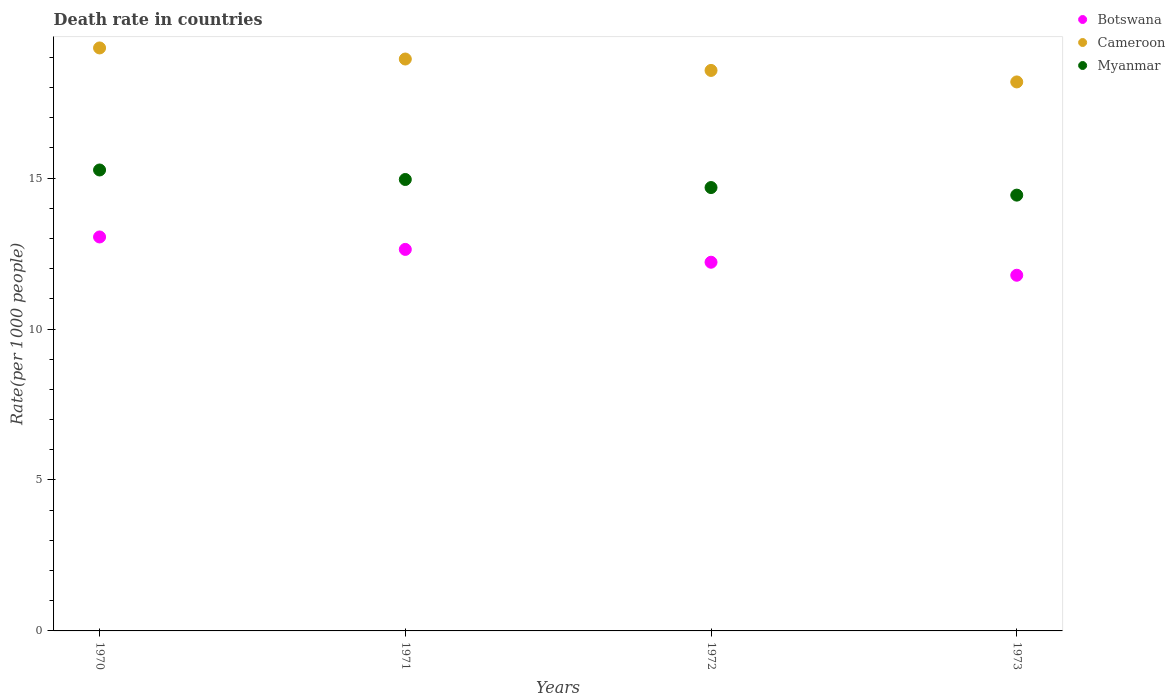Is the number of dotlines equal to the number of legend labels?
Offer a terse response. Yes. What is the death rate in Cameroon in 1972?
Ensure brevity in your answer.  18.57. Across all years, what is the maximum death rate in Botswana?
Your answer should be very brief. 13.05. Across all years, what is the minimum death rate in Botswana?
Offer a terse response. 11.78. What is the total death rate in Cameroon in the graph?
Your answer should be compact. 75.01. What is the difference between the death rate in Myanmar in 1972 and that in 1973?
Make the answer very short. 0.25. What is the difference between the death rate in Myanmar in 1971 and the death rate in Cameroon in 1970?
Your response must be concise. -4.36. What is the average death rate in Cameroon per year?
Your response must be concise. 18.75. In the year 1970, what is the difference between the death rate in Cameroon and death rate in Botswana?
Provide a short and direct response. 6.26. What is the ratio of the death rate in Botswana in 1970 to that in 1973?
Your answer should be very brief. 1.11. Is the death rate in Myanmar in 1970 less than that in 1973?
Give a very brief answer. No. Is the difference between the death rate in Cameroon in 1972 and 1973 greater than the difference between the death rate in Botswana in 1972 and 1973?
Offer a very short reply. No. What is the difference between the highest and the second highest death rate in Cameroon?
Your answer should be very brief. 0.37. What is the difference between the highest and the lowest death rate in Myanmar?
Make the answer very short. 0.83. In how many years, is the death rate in Botswana greater than the average death rate in Botswana taken over all years?
Make the answer very short. 2. Is the sum of the death rate in Myanmar in 1970 and 1972 greater than the maximum death rate in Botswana across all years?
Your response must be concise. Yes. Does the death rate in Cameroon monotonically increase over the years?
Offer a very short reply. No. Is the death rate in Cameroon strictly greater than the death rate in Myanmar over the years?
Your answer should be compact. Yes. How many years are there in the graph?
Give a very brief answer. 4. Are the values on the major ticks of Y-axis written in scientific E-notation?
Your answer should be very brief. No. Does the graph contain any zero values?
Offer a very short reply. No. Where does the legend appear in the graph?
Provide a short and direct response. Top right. How many legend labels are there?
Provide a succinct answer. 3. What is the title of the graph?
Your response must be concise. Death rate in countries. Does "Benin" appear as one of the legend labels in the graph?
Offer a very short reply. No. What is the label or title of the Y-axis?
Keep it short and to the point. Rate(per 1000 people). What is the Rate(per 1000 people) of Botswana in 1970?
Provide a succinct answer. 13.05. What is the Rate(per 1000 people) of Cameroon in 1970?
Give a very brief answer. 19.31. What is the Rate(per 1000 people) of Myanmar in 1970?
Offer a terse response. 15.27. What is the Rate(per 1000 people) of Botswana in 1971?
Your answer should be compact. 12.64. What is the Rate(per 1000 people) in Cameroon in 1971?
Provide a succinct answer. 18.95. What is the Rate(per 1000 people) of Myanmar in 1971?
Offer a very short reply. 14.96. What is the Rate(per 1000 people) in Botswana in 1972?
Your answer should be very brief. 12.21. What is the Rate(per 1000 people) of Cameroon in 1972?
Keep it short and to the point. 18.57. What is the Rate(per 1000 people) of Myanmar in 1972?
Ensure brevity in your answer.  14.69. What is the Rate(per 1000 people) in Botswana in 1973?
Give a very brief answer. 11.78. What is the Rate(per 1000 people) of Cameroon in 1973?
Ensure brevity in your answer.  18.19. What is the Rate(per 1000 people) in Myanmar in 1973?
Your answer should be compact. 14.44. Across all years, what is the maximum Rate(per 1000 people) of Botswana?
Keep it short and to the point. 13.05. Across all years, what is the maximum Rate(per 1000 people) of Cameroon?
Provide a short and direct response. 19.31. Across all years, what is the maximum Rate(per 1000 people) in Myanmar?
Provide a short and direct response. 15.27. Across all years, what is the minimum Rate(per 1000 people) in Botswana?
Your response must be concise. 11.78. Across all years, what is the minimum Rate(per 1000 people) of Cameroon?
Your answer should be very brief. 18.19. Across all years, what is the minimum Rate(per 1000 people) of Myanmar?
Your response must be concise. 14.44. What is the total Rate(per 1000 people) of Botswana in the graph?
Your response must be concise. 49.69. What is the total Rate(per 1000 people) in Cameroon in the graph?
Give a very brief answer. 75.01. What is the total Rate(per 1000 people) of Myanmar in the graph?
Provide a succinct answer. 59.35. What is the difference between the Rate(per 1000 people) in Botswana in 1970 and that in 1971?
Keep it short and to the point. 0.41. What is the difference between the Rate(per 1000 people) of Cameroon in 1970 and that in 1971?
Give a very brief answer. 0.37. What is the difference between the Rate(per 1000 people) of Myanmar in 1970 and that in 1971?
Make the answer very short. 0.32. What is the difference between the Rate(per 1000 people) of Botswana in 1970 and that in 1972?
Offer a terse response. 0.84. What is the difference between the Rate(per 1000 people) in Cameroon in 1970 and that in 1972?
Your response must be concise. 0.74. What is the difference between the Rate(per 1000 people) of Myanmar in 1970 and that in 1972?
Provide a succinct answer. 0.58. What is the difference between the Rate(per 1000 people) in Botswana in 1970 and that in 1973?
Offer a very short reply. 1.27. What is the difference between the Rate(per 1000 people) in Cameroon in 1970 and that in 1973?
Provide a succinct answer. 1.13. What is the difference between the Rate(per 1000 people) of Myanmar in 1970 and that in 1973?
Keep it short and to the point. 0.83. What is the difference between the Rate(per 1000 people) in Botswana in 1971 and that in 1972?
Offer a terse response. 0.42. What is the difference between the Rate(per 1000 people) in Cameroon in 1971 and that in 1972?
Provide a short and direct response. 0.38. What is the difference between the Rate(per 1000 people) of Myanmar in 1971 and that in 1972?
Make the answer very short. 0.27. What is the difference between the Rate(per 1000 people) in Botswana in 1971 and that in 1973?
Make the answer very short. 0.86. What is the difference between the Rate(per 1000 people) in Cameroon in 1971 and that in 1973?
Keep it short and to the point. 0.76. What is the difference between the Rate(per 1000 people) of Myanmar in 1971 and that in 1973?
Offer a very short reply. 0.52. What is the difference between the Rate(per 1000 people) in Botswana in 1972 and that in 1973?
Your answer should be very brief. 0.43. What is the difference between the Rate(per 1000 people) of Cameroon in 1972 and that in 1973?
Your answer should be compact. 0.38. What is the difference between the Rate(per 1000 people) of Myanmar in 1972 and that in 1973?
Offer a very short reply. 0.25. What is the difference between the Rate(per 1000 people) of Botswana in 1970 and the Rate(per 1000 people) of Cameroon in 1971?
Ensure brevity in your answer.  -5.89. What is the difference between the Rate(per 1000 people) in Botswana in 1970 and the Rate(per 1000 people) in Myanmar in 1971?
Make the answer very short. -1.9. What is the difference between the Rate(per 1000 people) of Cameroon in 1970 and the Rate(per 1000 people) of Myanmar in 1971?
Your answer should be very brief. 4.36. What is the difference between the Rate(per 1000 people) in Botswana in 1970 and the Rate(per 1000 people) in Cameroon in 1972?
Provide a succinct answer. -5.52. What is the difference between the Rate(per 1000 people) of Botswana in 1970 and the Rate(per 1000 people) of Myanmar in 1972?
Make the answer very short. -1.64. What is the difference between the Rate(per 1000 people) in Cameroon in 1970 and the Rate(per 1000 people) in Myanmar in 1972?
Keep it short and to the point. 4.62. What is the difference between the Rate(per 1000 people) in Botswana in 1970 and the Rate(per 1000 people) in Cameroon in 1973?
Give a very brief answer. -5.14. What is the difference between the Rate(per 1000 people) in Botswana in 1970 and the Rate(per 1000 people) in Myanmar in 1973?
Keep it short and to the point. -1.39. What is the difference between the Rate(per 1000 people) of Cameroon in 1970 and the Rate(per 1000 people) of Myanmar in 1973?
Give a very brief answer. 4.88. What is the difference between the Rate(per 1000 people) in Botswana in 1971 and the Rate(per 1000 people) in Cameroon in 1972?
Provide a short and direct response. -5.93. What is the difference between the Rate(per 1000 people) in Botswana in 1971 and the Rate(per 1000 people) in Myanmar in 1972?
Your answer should be compact. -2.05. What is the difference between the Rate(per 1000 people) of Cameroon in 1971 and the Rate(per 1000 people) of Myanmar in 1972?
Make the answer very short. 4.26. What is the difference between the Rate(per 1000 people) in Botswana in 1971 and the Rate(per 1000 people) in Cameroon in 1973?
Your response must be concise. -5.55. What is the difference between the Rate(per 1000 people) in Botswana in 1971 and the Rate(per 1000 people) in Myanmar in 1973?
Keep it short and to the point. -1.8. What is the difference between the Rate(per 1000 people) in Cameroon in 1971 and the Rate(per 1000 people) in Myanmar in 1973?
Keep it short and to the point. 4.51. What is the difference between the Rate(per 1000 people) of Botswana in 1972 and the Rate(per 1000 people) of Cameroon in 1973?
Keep it short and to the point. -5.97. What is the difference between the Rate(per 1000 people) of Botswana in 1972 and the Rate(per 1000 people) of Myanmar in 1973?
Your answer should be very brief. -2.22. What is the difference between the Rate(per 1000 people) of Cameroon in 1972 and the Rate(per 1000 people) of Myanmar in 1973?
Offer a very short reply. 4.13. What is the average Rate(per 1000 people) of Botswana per year?
Provide a short and direct response. 12.42. What is the average Rate(per 1000 people) in Cameroon per year?
Offer a terse response. 18.75. What is the average Rate(per 1000 people) in Myanmar per year?
Your response must be concise. 14.84. In the year 1970, what is the difference between the Rate(per 1000 people) of Botswana and Rate(per 1000 people) of Cameroon?
Your answer should be very brief. -6.26. In the year 1970, what is the difference between the Rate(per 1000 people) of Botswana and Rate(per 1000 people) of Myanmar?
Offer a very short reply. -2.22. In the year 1970, what is the difference between the Rate(per 1000 people) of Cameroon and Rate(per 1000 people) of Myanmar?
Your answer should be compact. 4.04. In the year 1971, what is the difference between the Rate(per 1000 people) of Botswana and Rate(per 1000 people) of Cameroon?
Provide a short and direct response. -6.31. In the year 1971, what is the difference between the Rate(per 1000 people) of Botswana and Rate(per 1000 people) of Myanmar?
Provide a succinct answer. -2.32. In the year 1971, what is the difference between the Rate(per 1000 people) of Cameroon and Rate(per 1000 people) of Myanmar?
Provide a short and direct response. 3.99. In the year 1972, what is the difference between the Rate(per 1000 people) of Botswana and Rate(per 1000 people) of Cameroon?
Make the answer very short. -6.35. In the year 1972, what is the difference between the Rate(per 1000 people) in Botswana and Rate(per 1000 people) in Myanmar?
Offer a terse response. -2.47. In the year 1972, what is the difference between the Rate(per 1000 people) in Cameroon and Rate(per 1000 people) in Myanmar?
Ensure brevity in your answer.  3.88. In the year 1973, what is the difference between the Rate(per 1000 people) of Botswana and Rate(per 1000 people) of Cameroon?
Give a very brief answer. -6.4. In the year 1973, what is the difference between the Rate(per 1000 people) in Botswana and Rate(per 1000 people) in Myanmar?
Your response must be concise. -2.65. In the year 1973, what is the difference between the Rate(per 1000 people) in Cameroon and Rate(per 1000 people) in Myanmar?
Provide a succinct answer. 3.75. What is the ratio of the Rate(per 1000 people) in Botswana in 1970 to that in 1971?
Ensure brevity in your answer.  1.03. What is the ratio of the Rate(per 1000 people) of Cameroon in 1970 to that in 1971?
Provide a short and direct response. 1.02. What is the ratio of the Rate(per 1000 people) in Myanmar in 1970 to that in 1971?
Keep it short and to the point. 1.02. What is the ratio of the Rate(per 1000 people) of Botswana in 1970 to that in 1972?
Give a very brief answer. 1.07. What is the ratio of the Rate(per 1000 people) in Cameroon in 1970 to that in 1972?
Make the answer very short. 1.04. What is the ratio of the Rate(per 1000 people) of Myanmar in 1970 to that in 1972?
Make the answer very short. 1.04. What is the ratio of the Rate(per 1000 people) in Botswana in 1970 to that in 1973?
Give a very brief answer. 1.11. What is the ratio of the Rate(per 1000 people) of Cameroon in 1970 to that in 1973?
Provide a short and direct response. 1.06. What is the ratio of the Rate(per 1000 people) in Myanmar in 1970 to that in 1973?
Your response must be concise. 1.06. What is the ratio of the Rate(per 1000 people) of Botswana in 1971 to that in 1972?
Provide a succinct answer. 1.03. What is the ratio of the Rate(per 1000 people) in Cameroon in 1971 to that in 1972?
Your answer should be compact. 1.02. What is the ratio of the Rate(per 1000 people) in Myanmar in 1971 to that in 1972?
Provide a succinct answer. 1.02. What is the ratio of the Rate(per 1000 people) of Botswana in 1971 to that in 1973?
Offer a terse response. 1.07. What is the ratio of the Rate(per 1000 people) in Cameroon in 1971 to that in 1973?
Keep it short and to the point. 1.04. What is the ratio of the Rate(per 1000 people) of Myanmar in 1971 to that in 1973?
Make the answer very short. 1.04. What is the ratio of the Rate(per 1000 people) in Botswana in 1972 to that in 1973?
Offer a very short reply. 1.04. What is the ratio of the Rate(per 1000 people) of Cameroon in 1972 to that in 1973?
Give a very brief answer. 1.02. What is the ratio of the Rate(per 1000 people) of Myanmar in 1972 to that in 1973?
Ensure brevity in your answer.  1.02. What is the difference between the highest and the second highest Rate(per 1000 people) in Botswana?
Provide a short and direct response. 0.41. What is the difference between the highest and the second highest Rate(per 1000 people) in Cameroon?
Your answer should be very brief. 0.37. What is the difference between the highest and the second highest Rate(per 1000 people) in Myanmar?
Your answer should be compact. 0.32. What is the difference between the highest and the lowest Rate(per 1000 people) in Botswana?
Offer a very short reply. 1.27. What is the difference between the highest and the lowest Rate(per 1000 people) in Cameroon?
Your answer should be very brief. 1.13. What is the difference between the highest and the lowest Rate(per 1000 people) in Myanmar?
Offer a very short reply. 0.83. 